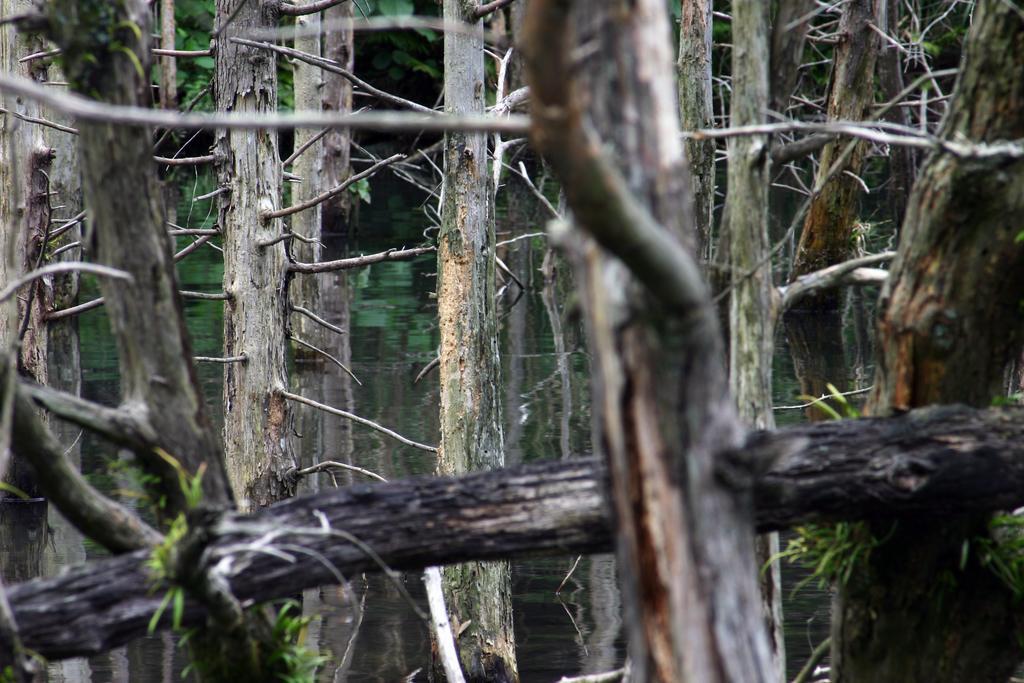Please provide a concise description of this image. In this image I can see dried trees. Background I can see few trees in green color. 